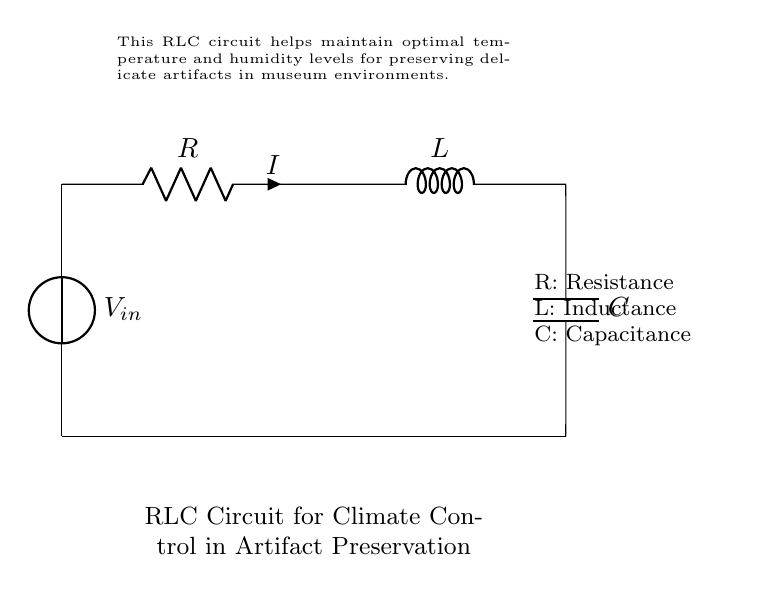What type of circuit is shown here? This circuit is an RLC circuit, which includes a resistor, inductor, and capacitor connected in series. The components are labeled with R for resistance, L for inductance, and C for capacitance.
Answer: RLC circuit What does the `R` represent in the circuit? The `R` in the circuit represents resistance, a measure of the opposition to current flow. It is one of the main components of the RLC circuit diagram.
Answer: Resistance Which component helps to store electrical energy in this circuit? The component that helps to store electrical energy is the capacitor, labeled as `C`. It stores energy in an electric field when it is charged.
Answer: Capacitor What is the primary purpose of this RLC circuit? The primary purpose of this RLC circuit is to maintain optimal temperature and humidity levels for preserving artifacts in a museum environment. This is facilitated by the interaction of the components.
Answer: Climate control How does the `L` in the circuit affect current flow? The `L` represents inductance, which affects current flow by resisting changes in the current due to its stored magnetic energy. Inductors can delay current changes and smooth out fluctuations.
Answer: Delays current changes What does the voltage source `V_in` provide in this circuit? The voltage source `V_in` provides the electrical potential that drives the current through the RLC circuit. Without this voltage, there would be no current flowing in the circuit.
Answer: Electrical potential 